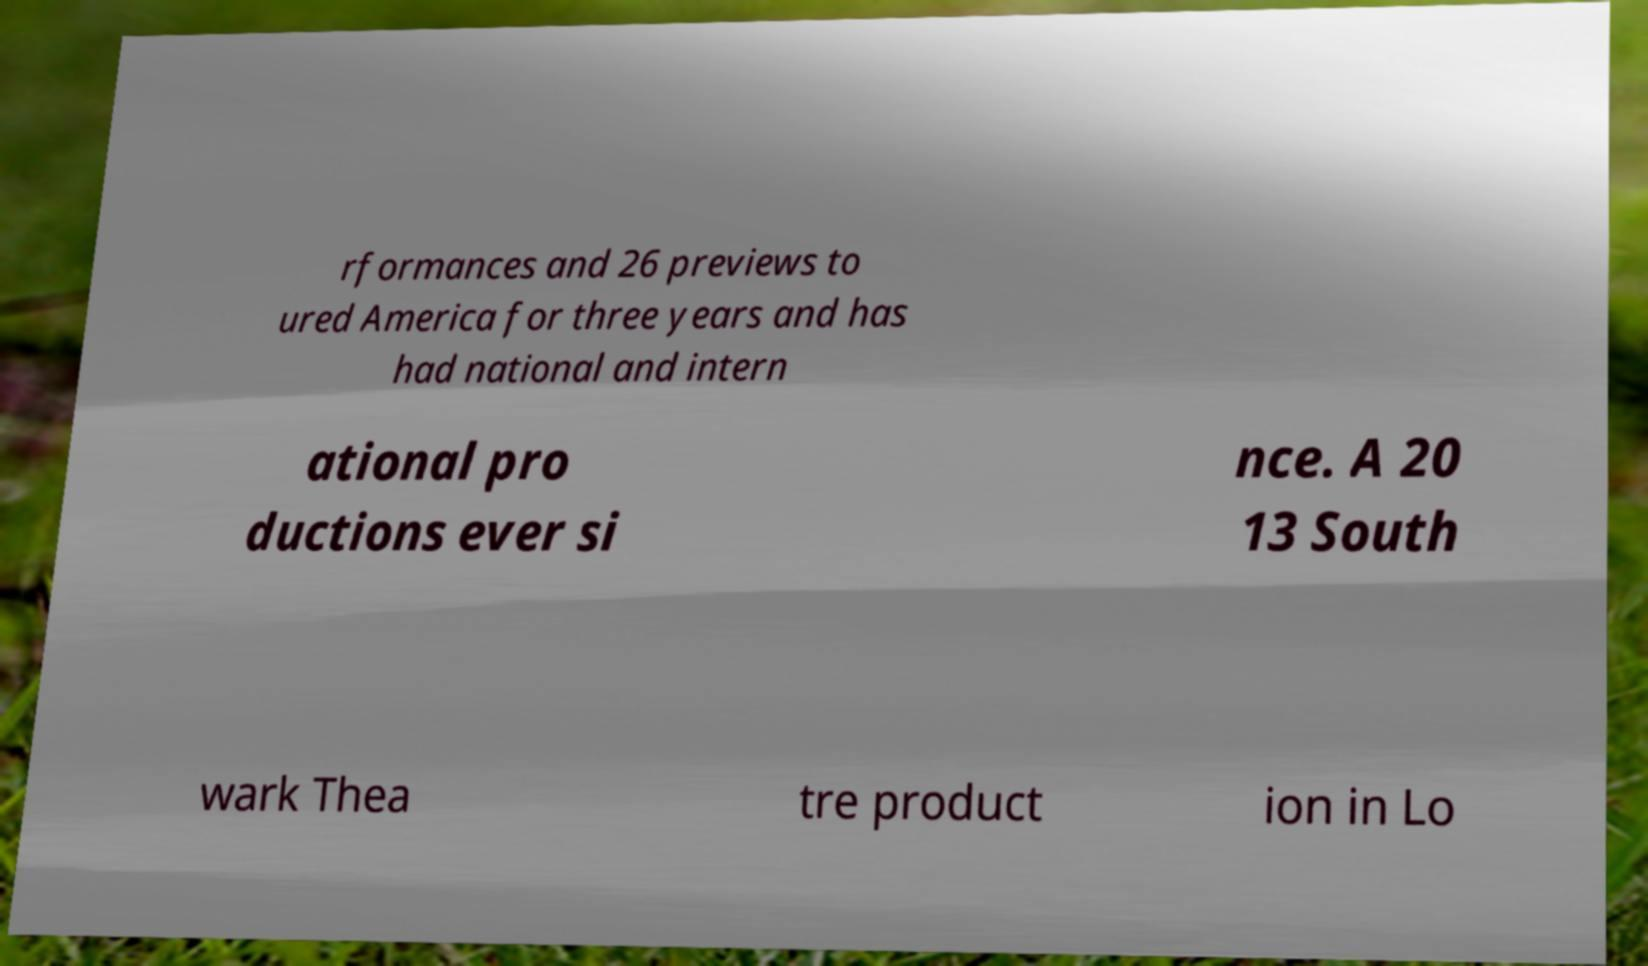There's text embedded in this image that I need extracted. Can you transcribe it verbatim? rformances and 26 previews to ured America for three years and has had national and intern ational pro ductions ever si nce. A 20 13 South wark Thea tre product ion in Lo 